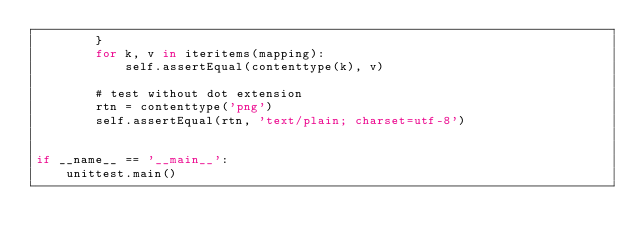Convert code to text. <code><loc_0><loc_0><loc_500><loc_500><_Python_>        }
        for k, v in iteritems(mapping):
            self.assertEqual(contenttype(k), v)

        # test without dot extension
        rtn = contenttype('png')
        self.assertEqual(rtn, 'text/plain; charset=utf-8')


if __name__ == '__main__':
    unittest.main()
</code> 